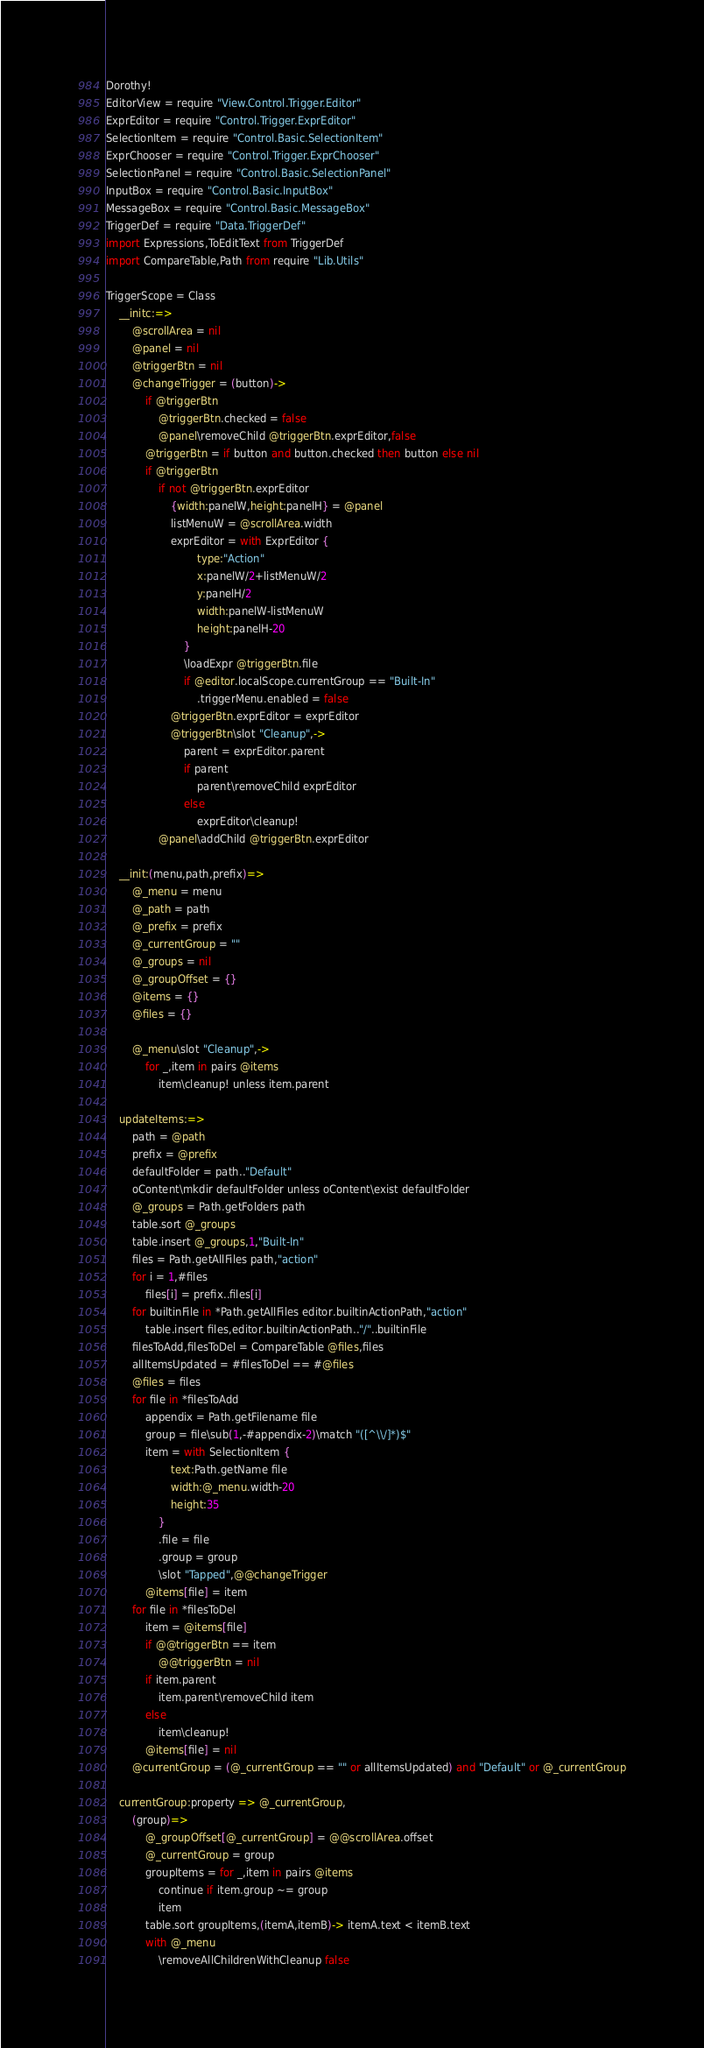Convert code to text. <code><loc_0><loc_0><loc_500><loc_500><_MoonScript_>Dorothy!
EditorView = require "View.Control.Trigger.Editor"
ExprEditor = require "Control.Trigger.ExprEditor"
SelectionItem = require "Control.Basic.SelectionItem"
ExprChooser = require "Control.Trigger.ExprChooser"
SelectionPanel = require "Control.Basic.SelectionPanel"
InputBox = require "Control.Basic.InputBox"
MessageBox = require "Control.Basic.MessageBox"
TriggerDef = require "Data.TriggerDef"
import Expressions,ToEditText from TriggerDef
import CompareTable,Path from require "Lib.Utils"

TriggerScope = Class
	__initc:=>
		@scrollArea = nil
		@panel = nil
		@triggerBtn = nil
		@changeTrigger = (button)->
			if @triggerBtn
				@triggerBtn.checked = false
				@panel\removeChild @triggerBtn.exprEditor,false
			@triggerBtn = if button and button.checked then button else nil
			if @triggerBtn
				if not @triggerBtn.exprEditor
					{width:panelW,height:panelH} = @panel
					listMenuW = @scrollArea.width
					exprEditor = with ExprEditor {
							type:"Action"
							x:panelW/2+listMenuW/2
							y:panelH/2
							width:panelW-listMenuW
							height:panelH-20
						}
						\loadExpr @triggerBtn.file
						if @editor.localScope.currentGroup == "Built-In"
							.triggerMenu.enabled = false
					@triggerBtn.exprEditor = exprEditor
					@triggerBtn\slot "Cleanup",->
						parent = exprEditor.parent
						if parent
							parent\removeChild exprEditor
						else
							exprEditor\cleanup!
				@panel\addChild @triggerBtn.exprEditor

	__init:(menu,path,prefix)=>
		@_menu = menu
		@_path = path
		@_prefix = prefix
		@_currentGroup = ""
		@_groups = nil
		@_groupOffset = {}
		@items = {}
		@files = {}

		@_menu\slot "Cleanup",->
			for _,item in pairs @items
				item\cleanup! unless item.parent

	updateItems:=>
		path = @path
		prefix = @prefix
		defaultFolder = path.."Default"
		oContent\mkdir defaultFolder unless oContent\exist defaultFolder
		@_groups = Path.getFolders path
		table.sort @_groups
		table.insert @_groups,1,"Built-In"
		files = Path.getAllFiles path,"action"
		for i = 1,#files
			files[i] = prefix..files[i]
		for builtinFile in *Path.getAllFiles editor.builtinActionPath,"action"
			table.insert files,editor.builtinActionPath.."/"..builtinFile
		filesToAdd,filesToDel = CompareTable @files,files
		allItemsUpdated = #filesToDel == #@files
		@files = files
		for file in *filesToAdd
			appendix = Path.getFilename file
			group = file\sub(1,-#appendix-2)\match "([^\\/]*)$"
			item = with SelectionItem {
					text:Path.getName file
					width:@_menu.width-20
					height:35
				}
				.file = file
				.group = group
				\slot "Tapped",@@changeTrigger
			@items[file] = item
		for file in *filesToDel
			item = @items[file]
			if @@triggerBtn == item
				@@triggerBtn = nil
			if item.parent
				item.parent\removeChild item
			else
				item\cleanup!
			@items[file] = nil
		@currentGroup = (@_currentGroup == "" or allItemsUpdated) and "Default" or @_currentGroup

	currentGroup:property => @_currentGroup,
		(group)=>
			@_groupOffset[@_currentGroup] = @@scrollArea.offset
			@_currentGroup = group
			groupItems = for _,item in pairs @items
				continue if item.group ~= group
				item
			table.sort groupItems,(itemA,itemB)-> itemA.text < itemB.text
			with @_menu
				\removeAllChildrenWithCleanup false</code> 